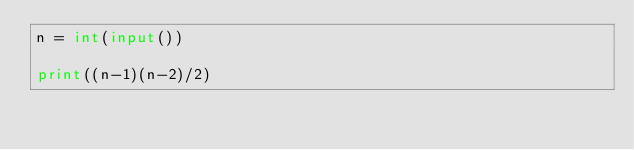<code> <loc_0><loc_0><loc_500><loc_500><_Python_>n = int(input())

print((n-1)(n-2)/2)</code> 